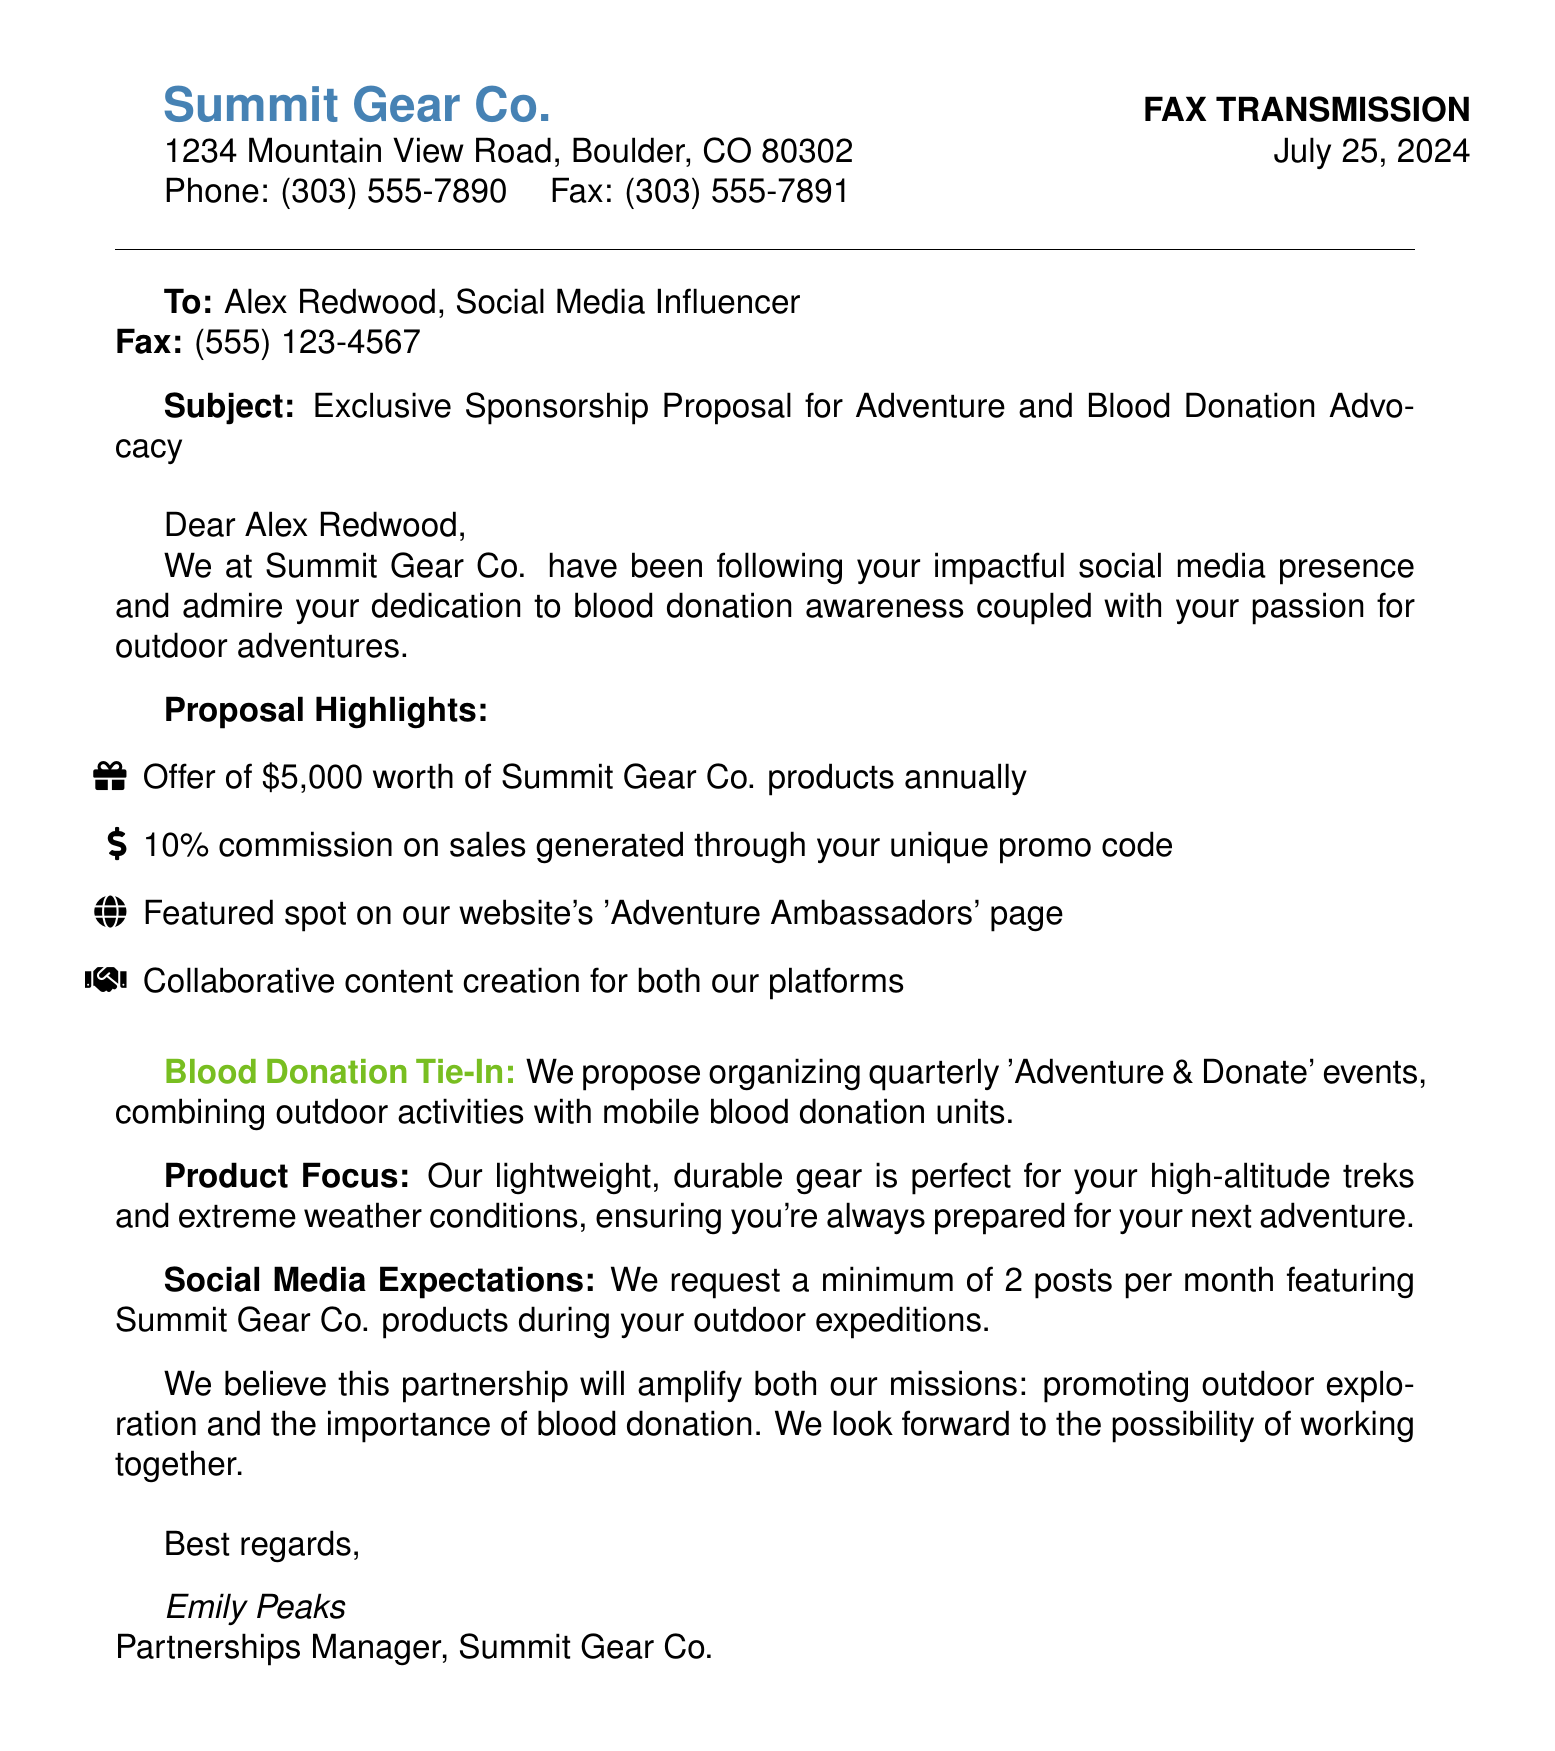What is the name of the company sending the fax? The name of the company is provided in the header of the fax.
Answer: Summit Gear Co What is the proposal amount offered annually? The proposal amount is specified under the proposal highlights.
Answer: $5,000 Who is the fax addressed to? The recipient of the fax is mentioned at the top of the document.
Answer: Alex Redwood What percentage commission will be provided on sales? The commission percentage is listed in the proposal highlights.
Answer: 10% What events are proposed to tie in with blood donation? The nature of the events is mentioned in the blood donation tie-in section.
Answer: 'Adventure & Donate' How many social media posts are expected each month? The expectation for posts is indicated in the social media expectations section.
Answer: 2 posts What type of products will be highlighted in the partnership? The focus of the products is mentioned in the product focus section.
Answer: Lightweight, durable gear Who signed the fax? The name of the person who signed the fax is provided at the end.
Answer: Emily Peaks What is the title of the sender? The title of the sender is indicated below the name in the signature.
Answer: Partnerships Manager 